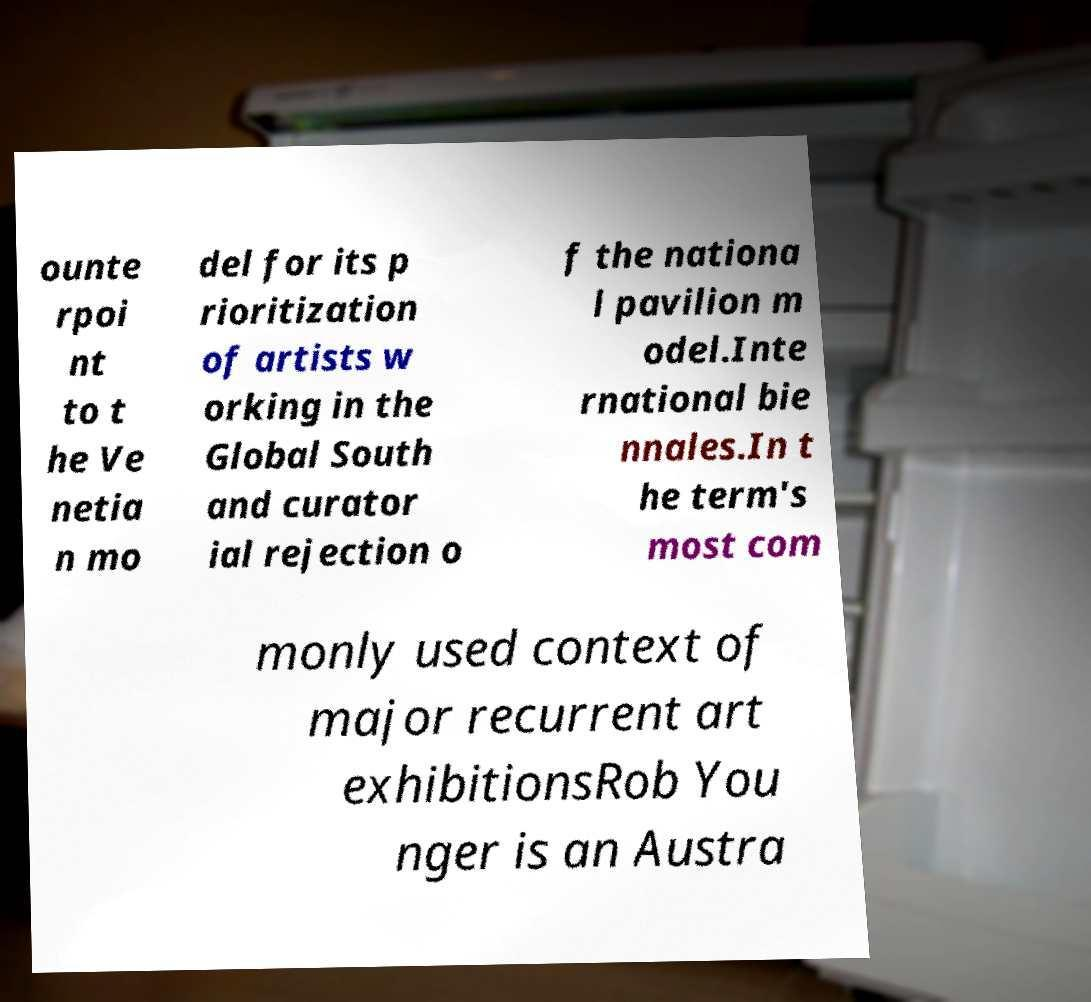What messages or text are displayed in this image? I need them in a readable, typed format. ounte rpoi nt to t he Ve netia n mo del for its p rioritization of artists w orking in the Global South and curator ial rejection o f the nationa l pavilion m odel.Inte rnational bie nnales.In t he term's most com monly used context of major recurrent art exhibitionsRob You nger is an Austra 